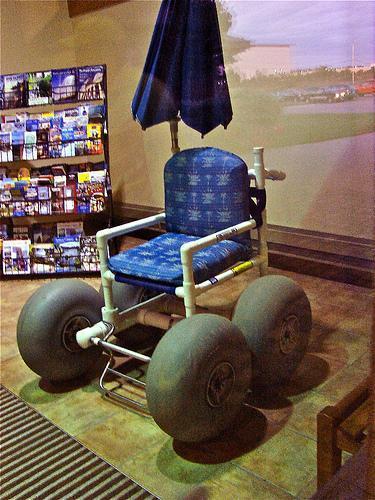How many chairs are there?
Give a very brief answer. 2. How many sheep are part of the herd?
Give a very brief answer. 0. 